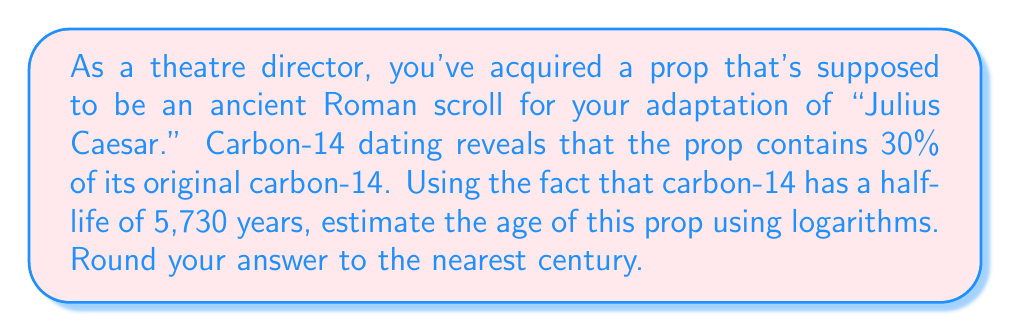Solve this math problem. Let's approach this step-by-step:

1) The decay of carbon-14 follows the exponential decay formula:
   $$ N(t) = N_0 \cdot (0.5)^{t/t_{1/2}} $$
   where $N(t)$ is the amount remaining after time $t$, $N_0$ is the initial amount, and $t_{1/2}$ is the half-life.

2) We're told that 30% of the original carbon-14 remains, so:
   $$ 0.30 = (0.5)^{t/5730} $$

3) To solve for $t$, we need to use logarithms. Let's apply $\log$ to both sides:
   $$ \log(0.30) = \log((0.5)^{t/5730}) $$

4) Using the logarithm property $\log(a^b) = b\log(a)$:
   $$ \log(0.30) = \frac{t}{5730} \log(0.5) $$

5) Now we can solve for $t$:
   $$ t = 5730 \cdot \frac{\log(0.30)}{\log(0.5)} $$

6) Using a calculator:
   $$ t \approx 9967.7 \text{ years} $$

7) Rounding to the nearest century:
   $$ t \approx 10,000 \text{ years} $$
Answer: 10,000 years 